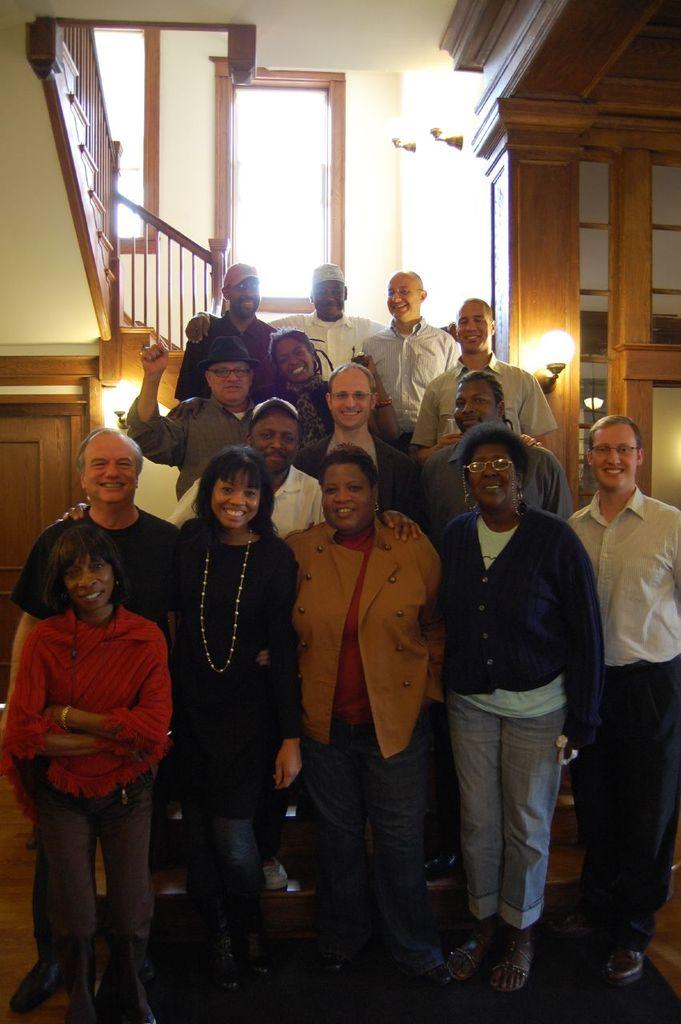How many people are in the image? There is a group of people in the image, but the exact number cannot be determined from the provided facts. What can be seen in the background of the image? In the background of the image, there is a wall, lights, a staircase, and some objects. Can you describe the lighting in the image? The presence of lights in the background of the image suggests that the area is well-lit. What type of objects can be seen in the background of the image? The provided facts do not specify the type of objects present in the background of the image. What type of breakfast is being served in the image? There is no mention of breakfast in the provided facts, and therefore it cannot be determined from the image. 